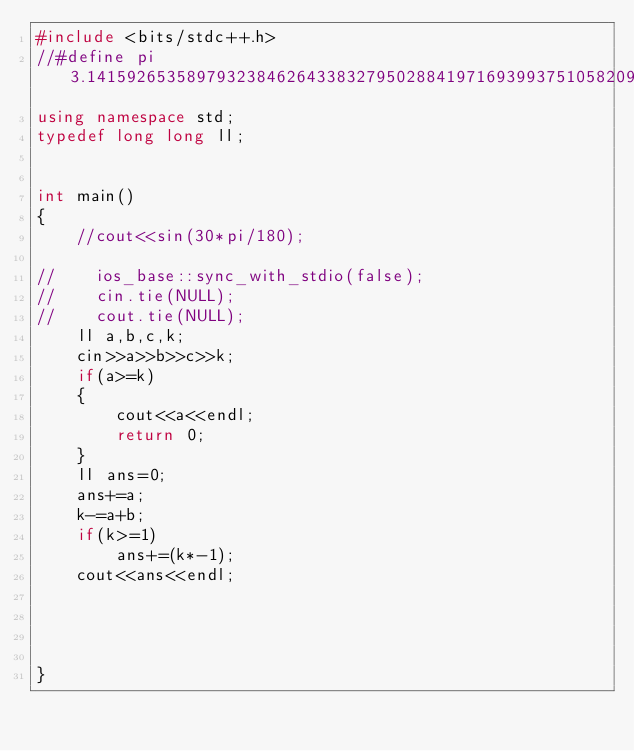Convert code to text. <code><loc_0><loc_0><loc_500><loc_500><_C++_>#include <bits/stdc++.h>
//#define pi 3.141592653589793238462643383279502884197169399375105820974944592307816406
using namespace std;
typedef long long ll;


int main()
{
    //cout<<sin(30*pi/180);

//    ios_base::sync_with_stdio(false);
//    cin.tie(NULL);
//    cout.tie(NULL);
    ll a,b,c,k;
    cin>>a>>b>>c>>k;
    if(a>=k)
    {
        cout<<a<<endl;
        return 0;
    }
    ll ans=0;
    ans+=a;
    k-=a+b;
    if(k>=1)
        ans+=(k*-1);
    cout<<ans<<endl;




}
</code> 